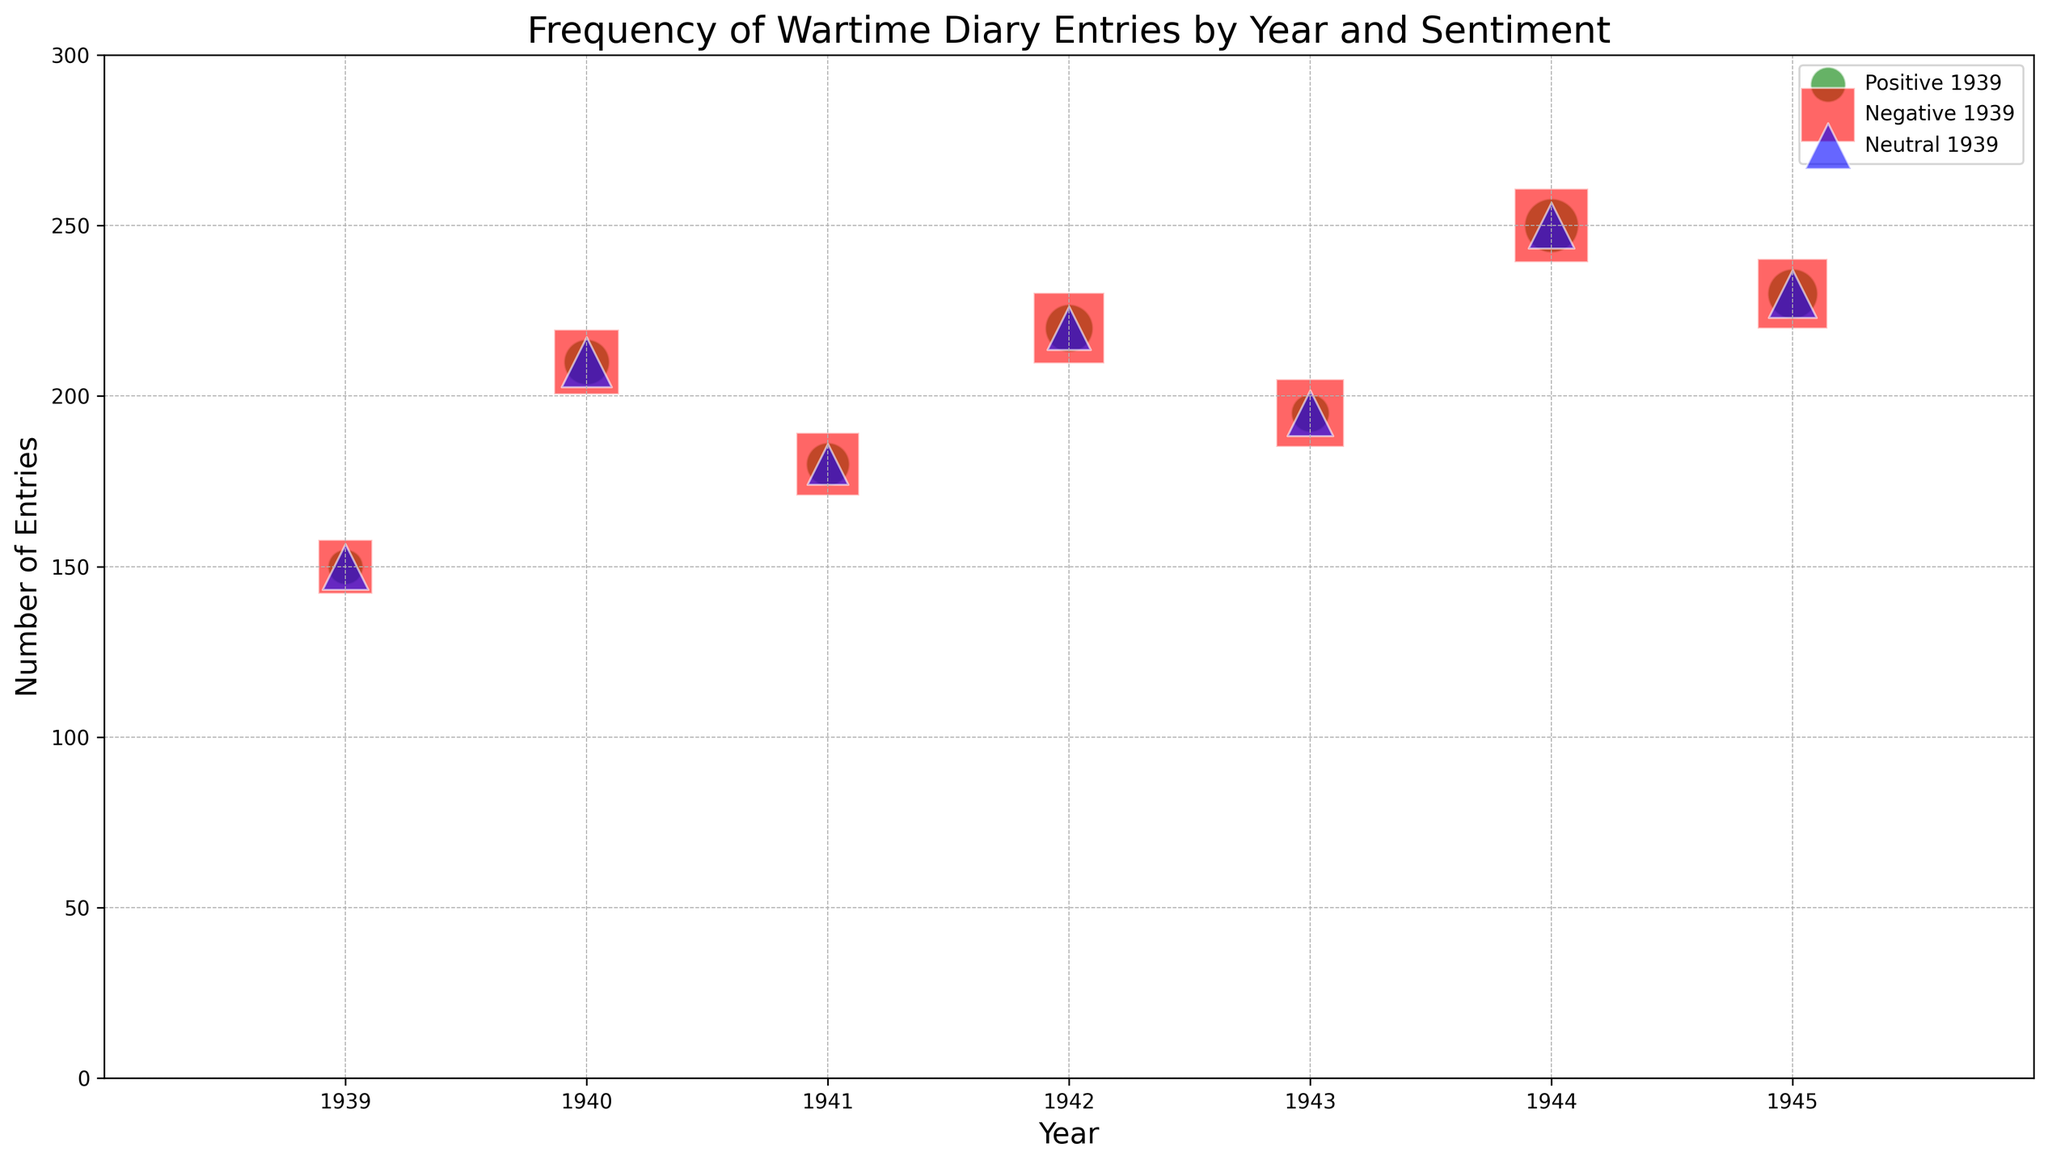Which year had the highest number of wartime diary entries? The highest point on the y-axis corresponds to 250 entries, which occurs in 1944.
Answer: 1944 Which sentiment had the most entries in 1942, and how many were there? In 1942, the highest bubble size corresponds to negative sentiment with 120 entries.
Answer: Negative, 120 What is the yearly trend for positive diary entries from 1939 to 1945? Observing the green bubbles for positive sentiment, the sizes gradually increase from 1939 to 1944 and slightly decrease in 1945.
Answer: Increasing, then decreasing How do the neutral entries in 1940 compare to those in 1943? The bubble size for neutral entries in 1940 is larger than that in 1943, indicating more entries in 1940.
Answer: More in 1940 What is the total number of positive entries in the years 1939 and 1945? The sum of positive entries in 1939 (30) and 1945 (60) is 30 + 60 = 90.
Answer: 90 In which year was the difference between neutral and negative entries the smallest? By comparing the bubble sizes for neutral and negative sentiments each year, the smallest difference appears in 1941 where the difference is 95 - 40 = 55.
Answer: 1941 Which sentiment type has more entries in 1943, positive or negative? In 1943, the red bubble (negative) has 110 entries, whereas the green bubble (positive) has 35 entries, so negative is greater than positive.
Answer: Negative What is the ratio of negative to neutral entries in the year with the most overall entries? In 1944, with the most overall entries (250), the negative entries are 130 and the neutral entries are 50, so the ratio is 130:50 or 2.6:1.
Answer: 2.6:1 Which year had the lowest number of positive entries? The year with the smallest green bubble for positive sentiment is 1939 with 30 entries.
Answer: 1939 What is the total number of entries spanning all years? Summing the 'Entries' column from all years (150 + 210 + 180 + 220 + 195 + 250 + 230) results in 1435.
Answer: 1435 